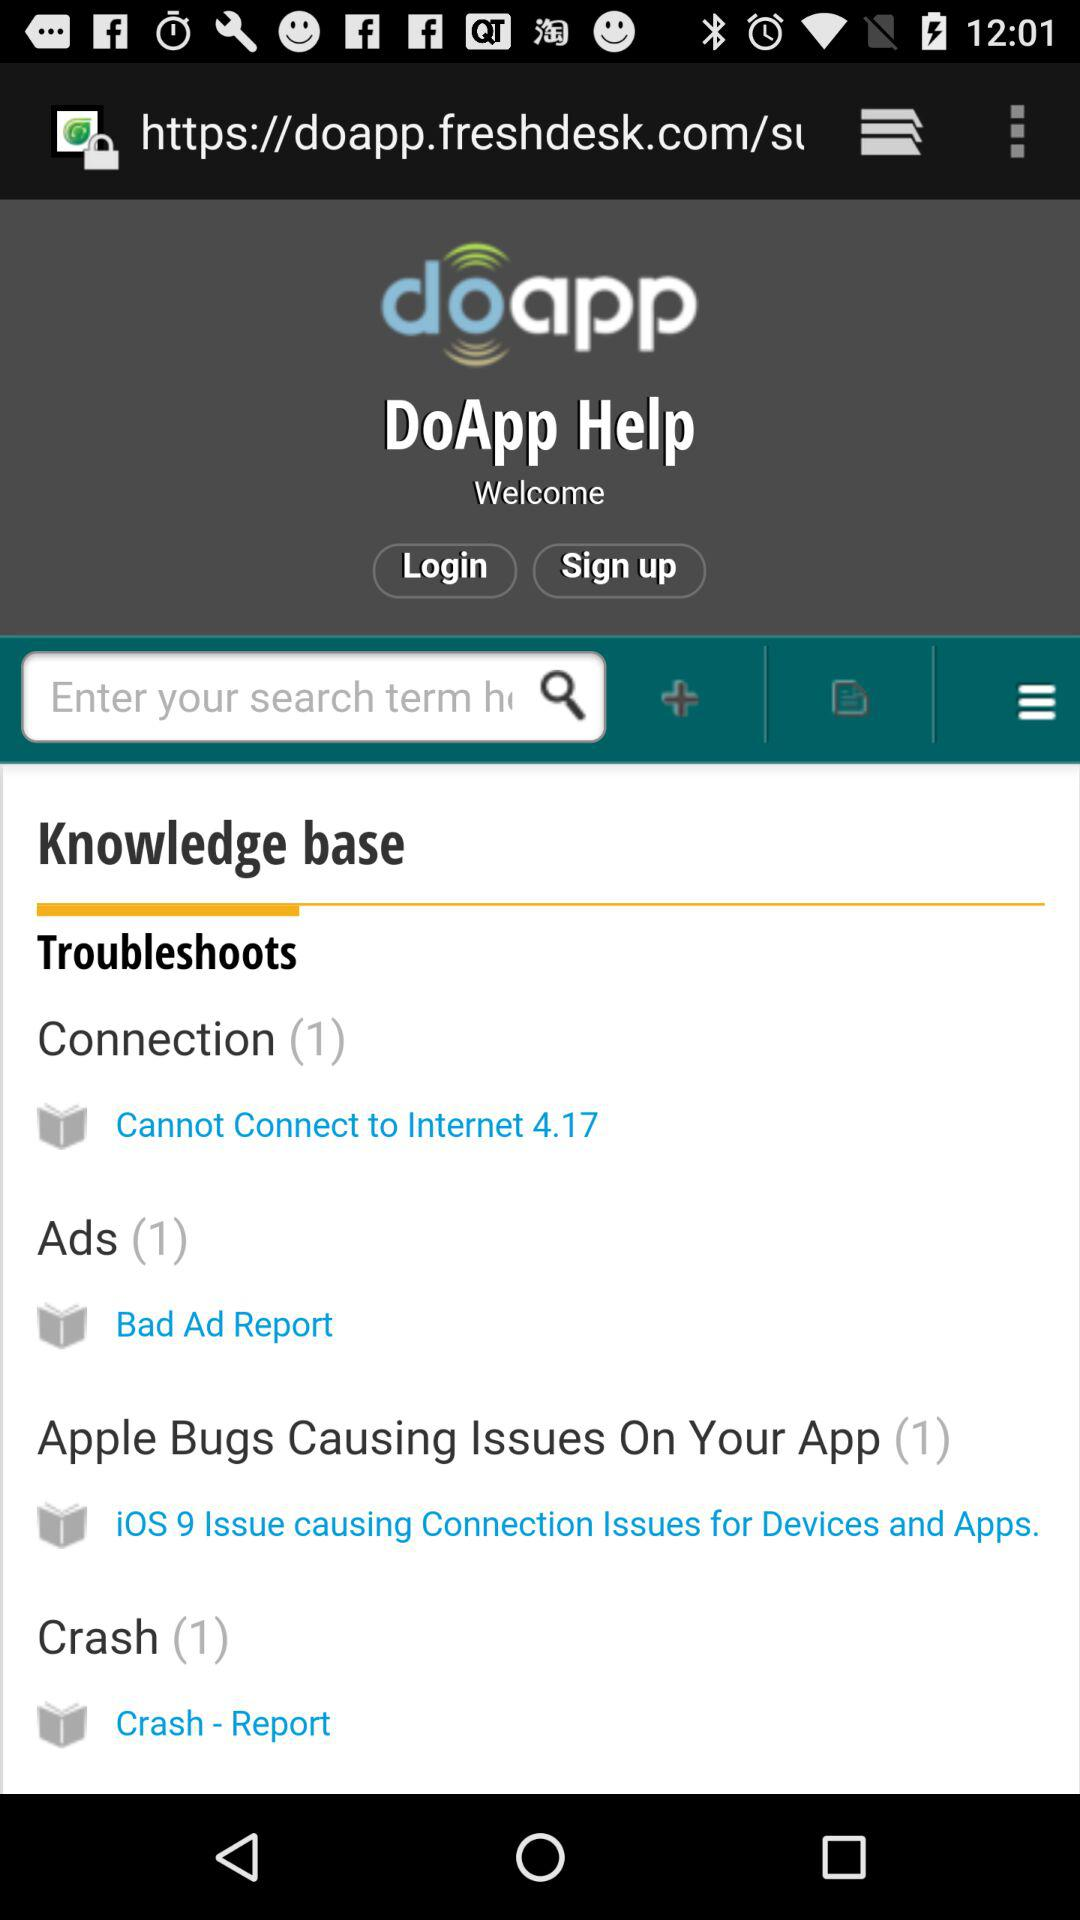How many Ads? There is 1 Ads. 